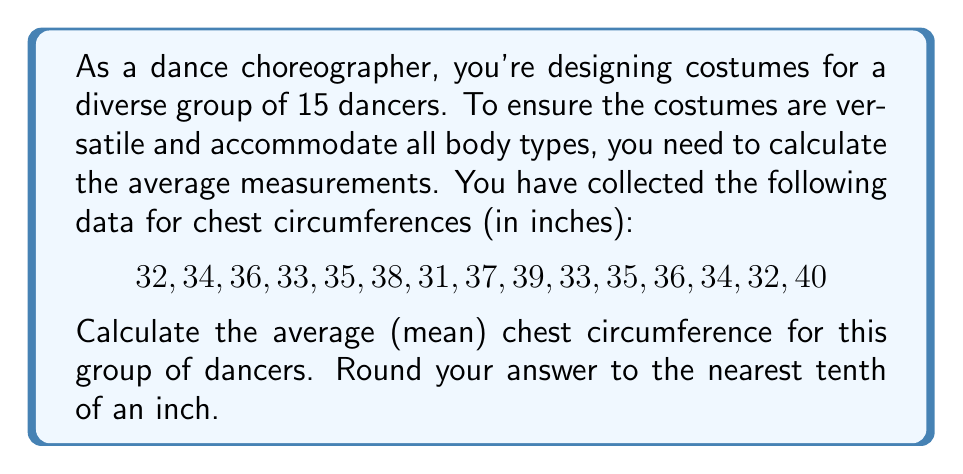Could you help me with this problem? To calculate the average (mean) chest circumference, we need to follow these steps:

1. Sum up all the measurements:
   $$\sum_{i=1}^{15} x_i = 32 + 34 + 36 + 33 + 35 + 38 + 31 + 37 + 39 + 33 + 35 + 36 + 34 + 32 + 40 = 525$$

2. Count the total number of dancers:
   $n = 15$

3. Apply the formula for the arithmetic mean:
   $$\bar{x} = \frac{\sum_{i=1}^{n} x_i}{n}$$

4. Substitute the values:
   $$\bar{x} = \frac{525}{15}$$

5. Perform the division:
   $$\bar{x} = 35$$

6. Round to the nearest tenth:
   The result is already a whole number, so it remains 35.0 inches.
Answer: The average chest circumference for the group of dancers is 35.0 inches. 